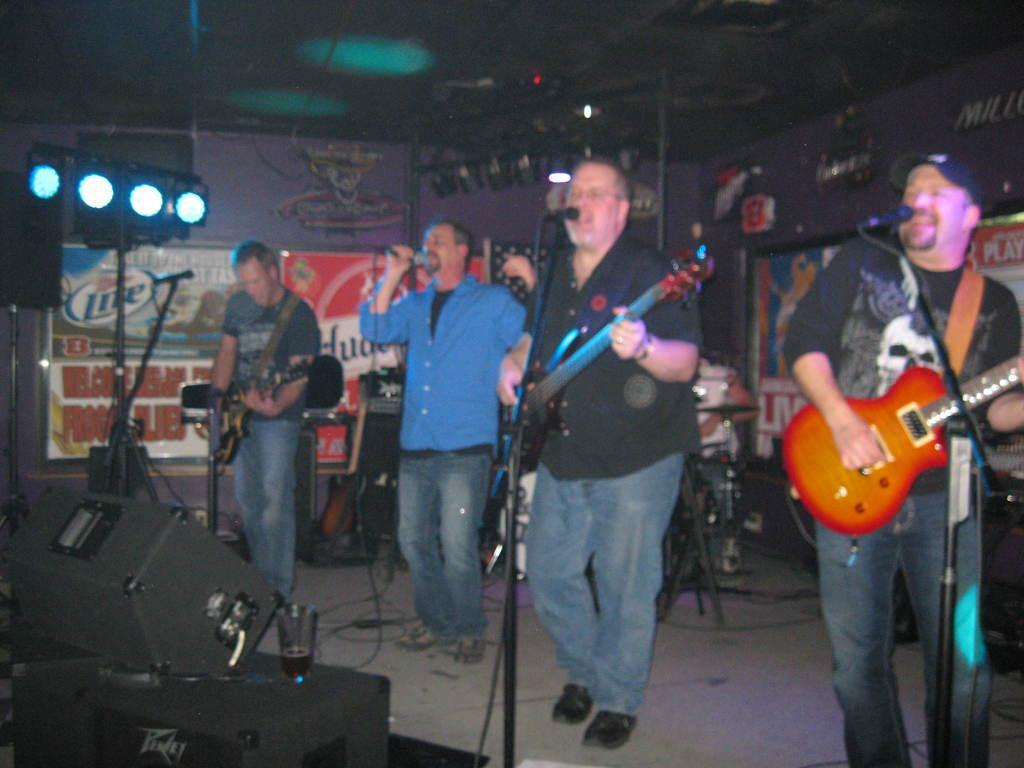Could you give a brief overview of what you see in this image? In this image I see 4 men in which these 3 are holding guitars and all of them are in front of the mic and this man is holding a mic. In the background I can see another musical instrument and I see lights and few equipment over here. 